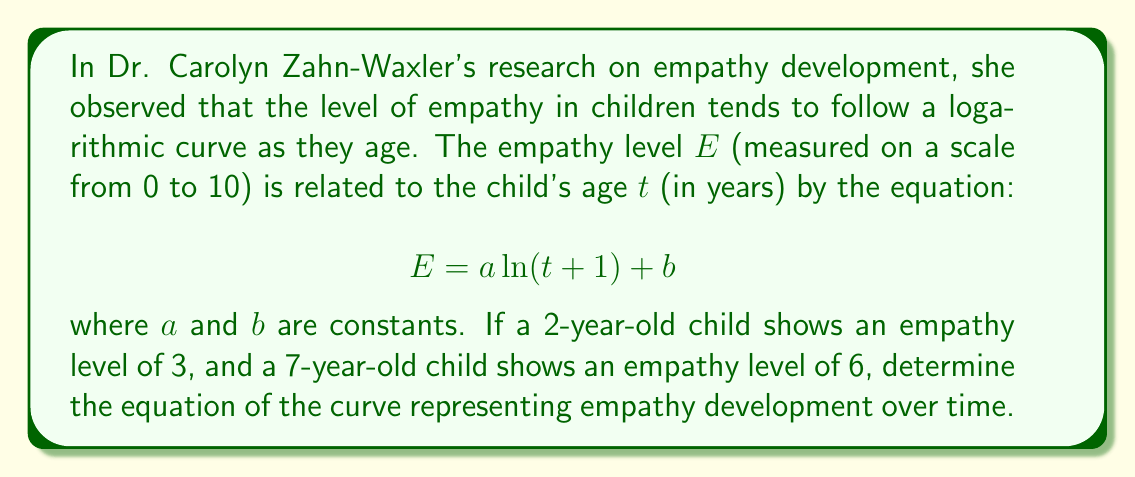Help me with this question. To solve this problem, we need to find the values of $a$ and $b$ using the given information. Let's approach this step-by-step:

1) We have two points on the curve:
   When $t = 2$, $E = 3$
   When $t = 7$, $E = 6$

2) Let's substitute these values into the general equation:
   For $t = 2$: $3 = a \ln(2 + 1) + b = a \ln(3) + b$
   For $t = 7$: $6 = a \ln(7 + 1) + b = a \ln(8) + b$

3) Now we have a system of two equations:
   $3 = a \ln(3) + b$
   $6 = a \ln(8) + b$

4) Subtracting the first equation from the second:
   $6 - 3 = a \ln(8) - a \ln(3)$
   $3 = a (\ln(8) - \ln(3))$
   $3 = a \ln(\frac{8}{3})$

5) Solving for $a$:
   $a = \frac{3}{\ln(\frac{8}{3})} \approx 2.466$

6) Now that we know $a$, we can substitute it back into either of the original equations to find $b$. Let's use the first equation:
   $3 = 2.466 \ln(3) + b$
   $b = 3 - 2.466 \ln(3) \approx 0.292$

7) Therefore, the equation of the curve is:
   $E = 2.466 \ln(t + 1) + 0.292$
Answer: The equation of the curve representing empathy development over time is:
$$E = 2.466 \ln(t + 1) + 0.292$$
where $E$ is the empathy level and $t$ is the age in years. 